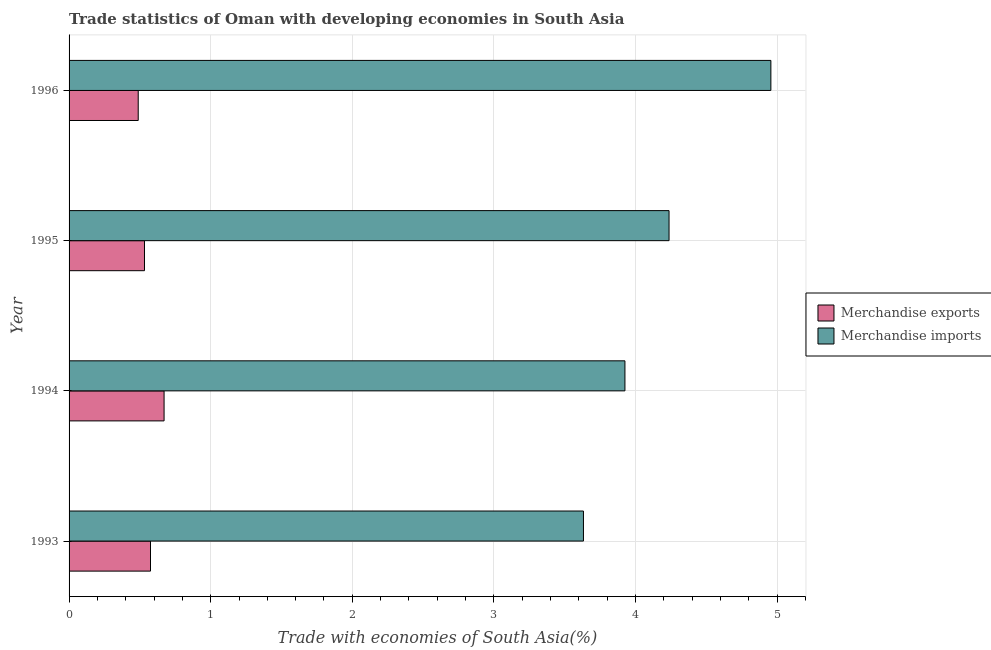How many different coloured bars are there?
Give a very brief answer. 2. Are the number of bars on each tick of the Y-axis equal?
Offer a terse response. Yes. What is the label of the 4th group of bars from the top?
Your response must be concise. 1993. In how many cases, is the number of bars for a given year not equal to the number of legend labels?
Give a very brief answer. 0. What is the merchandise exports in 1994?
Offer a very short reply. 0.67. Across all years, what is the maximum merchandise exports?
Offer a very short reply. 0.67. Across all years, what is the minimum merchandise imports?
Give a very brief answer. 3.63. What is the total merchandise imports in the graph?
Give a very brief answer. 16.75. What is the difference between the merchandise imports in 1994 and that in 1996?
Ensure brevity in your answer.  -1.03. What is the difference between the merchandise exports in 1995 and the merchandise imports in 1996?
Provide a succinct answer. -4.42. What is the average merchandise exports per year?
Your answer should be very brief. 0.57. In the year 1993, what is the difference between the merchandise imports and merchandise exports?
Your answer should be very brief. 3.06. In how many years, is the merchandise imports greater than 2.6 %?
Ensure brevity in your answer.  4. What is the ratio of the merchandise exports in 1994 to that in 1996?
Offer a very short reply. 1.37. Is the merchandise exports in 1993 less than that in 1994?
Ensure brevity in your answer.  Yes. Is the difference between the merchandise imports in 1995 and 1996 greater than the difference between the merchandise exports in 1995 and 1996?
Provide a succinct answer. No. What is the difference between the highest and the second highest merchandise exports?
Keep it short and to the point. 0.1. What is the difference between the highest and the lowest merchandise imports?
Your response must be concise. 1.32. What does the 2nd bar from the bottom in 1996 represents?
Make the answer very short. Merchandise imports. Are all the bars in the graph horizontal?
Offer a terse response. Yes. How many years are there in the graph?
Provide a succinct answer. 4. Are the values on the major ticks of X-axis written in scientific E-notation?
Your answer should be compact. No. Does the graph contain any zero values?
Provide a succinct answer. No. How are the legend labels stacked?
Ensure brevity in your answer.  Vertical. What is the title of the graph?
Provide a short and direct response. Trade statistics of Oman with developing economies in South Asia. Does "Research and Development" appear as one of the legend labels in the graph?
Make the answer very short. No. What is the label or title of the X-axis?
Your answer should be compact. Trade with economies of South Asia(%). What is the label or title of the Y-axis?
Offer a very short reply. Year. What is the Trade with economies of South Asia(%) in Merchandise exports in 1993?
Make the answer very short. 0.57. What is the Trade with economies of South Asia(%) of Merchandise imports in 1993?
Make the answer very short. 3.63. What is the Trade with economies of South Asia(%) of Merchandise exports in 1994?
Provide a succinct answer. 0.67. What is the Trade with economies of South Asia(%) of Merchandise imports in 1994?
Ensure brevity in your answer.  3.93. What is the Trade with economies of South Asia(%) of Merchandise exports in 1995?
Offer a terse response. 0.53. What is the Trade with economies of South Asia(%) in Merchandise imports in 1995?
Offer a very short reply. 4.24. What is the Trade with economies of South Asia(%) of Merchandise exports in 1996?
Offer a very short reply. 0.49. What is the Trade with economies of South Asia(%) of Merchandise imports in 1996?
Ensure brevity in your answer.  4.96. Across all years, what is the maximum Trade with economies of South Asia(%) in Merchandise exports?
Offer a terse response. 0.67. Across all years, what is the maximum Trade with economies of South Asia(%) in Merchandise imports?
Provide a succinct answer. 4.96. Across all years, what is the minimum Trade with economies of South Asia(%) in Merchandise exports?
Your answer should be compact. 0.49. Across all years, what is the minimum Trade with economies of South Asia(%) in Merchandise imports?
Your response must be concise. 3.63. What is the total Trade with economies of South Asia(%) in Merchandise exports in the graph?
Your answer should be very brief. 2.27. What is the total Trade with economies of South Asia(%) of Merchandise imports in the graph?
Offer a terse response. 16.75. What is the difference between the Trade with economies of South Asia(%) of Merchandise exports in 1993 and that in 1994?
Your answer should be compact. -0.1. What is the difference between the Trade with economies of South Asia(%) in Merchandise imports in 1993 and that in 1994?
Offer a terse response. -0.29. What is the difference between the Trade with economies of South Asia(%) in Merchandise exports in 1993 and that in 1995?
Keep it short and to the point. 0.04. What is the difference between the Trade with economies of South Asia(%) of Merchandise imports in 1993 and that in 1995?
Ensure brevity in your answer.  -0.6. What is the difference between the Trade with economies of South Asia(%) in Merchandise exports in 1993 and that in 1996?
Provide a succinct answer. 0.09. What is the difference between the Trade with economies of South Asia(%) of Merchandise imports in 1993 and that in 1996?
Keep it short and to the point. -1.32. What is the difference between the Trade with economies of South Asia(%) in Merchandise exports in 1994 and that in 1995?
Provide a succinct answer. 0.14. What is the difference between the Trade with economies of South Asia(%) of Merchandise imports in 1994 and that in 1995?
Your answer should be very brief. -0.31. What is the difference between the Trade with economies of South Asia(%) in Merchandise exports in 1994 and that in 1996?
Your answer should be very brief. 0.18. What is the difference between the Trade with economies of South Asia(%) in Merchandise imports in 1994 and that in 1996?
Your response must be concise. -1.03. What is the difference between the Trade with economies of South Asia(%) of Merchandise exports in 1995 and that in 1996?
Keep it short and to the point. 0.04. What is the difference between the Trade with economies of South Asia(%) of Merchandise imports in 1995 and that in 1996?
Keep it short and to the point. -0.72. What is the difference between the Trade with economies of South Asia(%) of Merchandise exports in 1993 and the Trade with economies of South Asia(%) of Merchandise imports in 1994?
Give a very brief answer. -3.35. What is the difference between the Trade with economies of South Asia(%) of Merchandise exports in 1993 and the Trade with economies of South Asia(%) of Merchandise imports in 1995?
Keep it short and to the point. -3.66. What is the difference between the Trade with economies of South Asia(%) in Merchandise exports in 1993 and the Trade with economies of South Asia(%) in Merchandise imports in 1996?
Provide a succinct answer. -4.38. What is the difference between the Trade with economies of South Asia(%) of Merchandise exports in 1994 and the Trade with economies of South Asia(%) of Merchandise imports in 1995?
Give a very brief answer. -3.57. What is the difference between the Trade with economies of South Asia(%) in Merchandise exports in 1994 and the Trade with economies of South Asia(%) in Merchandise imports in 1996?
Keep it short and to the point. -4.28. What is the difference between the Trade with economies of South Asia(%) of Merchandise exports in 1995 and the Trade with economies of South Asia(%) of Merchandise imports in 1996?
Your response must be concise. -4.42. What is the average Trade with economies of South Asia(%) in Merchandise exports per year?
Keep it short and to the point. 0.57. What is the average Trade with economies of South Asia(%) of Merchandise imports per year?
Provide a short and direct response. 4.19. In the year 1993, what is the difference between the Trade with economies of South Asia(%) in Merchandise exports and Trade with economies of South Asia(%) in Merchandise imports?
Give a very brief answer. -3.06. In the year 1994, what is the difference between the Trade with economies of South Asia(%) of Merchandise exports and Trade with economies of South Asia(%) of Merchandise imports?
Make the answer very short. -3.25. In the year 1995, what is the difference between the Trade with economies of South Asia(%) of Merchandise exports and Trade with economies of South Asia(%) of Merchandise imports?
Your answer should be very brief. -3.7. In the year 1996, what is the difference between the Trade with economies of South Asia(%) of Merchandise exports and Trade with economies of South Asia(%) of Merchandise imports?
Your answer should be compact. -4.47. What is the ratio of the Trade with economies of South Asia(%) in Merchandise imports in 1993 to that in 1994?
Offer a terse response. 0.93. What is the ratio of the Trade with economies of South Asia(%) in Merchandise exports in 1993 to that in 1995?
Provide a short and direct response. 1.08. What is the ratio of the Trade with economies of South Asia(%) of Merchandise imports in 1993 to that in 1995?
Your response must be concise. 0.86. What is the ratio of the Trade with economies of South Asia(%) in Merchandise exports in 1993 to that in 1996?
Your answer should be very brief. 1.18. What is the ratio of the Trade with economies of South Asia(%) in Merchandise imports in 1993 to that in 1996?
Your answer should be very brief. 0.73. What is the ratio of the Trade with economies of South Asia(%) in Merchandise exports in 1994 to that in 1995?
Provide a short and direct response. 1.26. What is the ratio of the Trade with economies of South Asia(%) of Merchandise imports in 1994 to that in 1995?
Ensure brevity in your answer.  0.93. What is the ratio of the Trade with economies of South Asia(%) in Merchandise exports in 1994 to that in 1996?
Keep it short and to the point. 1.37. What is the ratio of the Trade with economies of South Asia(%) of Merchandise imports in 1994 to that in 1996?
Give a very brief answer. 0.79. What is the ratio of the Trade with economies of South Asia(%) of Merchandise exports in 1995 to that in 1996?
Keep it short and to the point. 1.09. What is the ratio of the Trade with economies of South Asia(%) of Merchandise imports in 1995 to that in 1996?
Offer a very short reply. 0.85. What is the difference between the highest and the second highest Trade with economies of South Asia(%) in Merchandise exports?
Your answer should be very brief. 0.1. What is the difference between the highest and the second highest Trade with economies of South Asia(%) of Merchandise imports?
Your response must be concise. 0.72. What is the difference between the highest and the lowest Trade with economies of South Asia(%) of Merchandise exports?
Your answer should be very brief. 0.18. What is the difference between the highest and the lowest Trade with economies of South Asia(%) of Merchandise imports?
Provide a succinct answer. 1.32. 